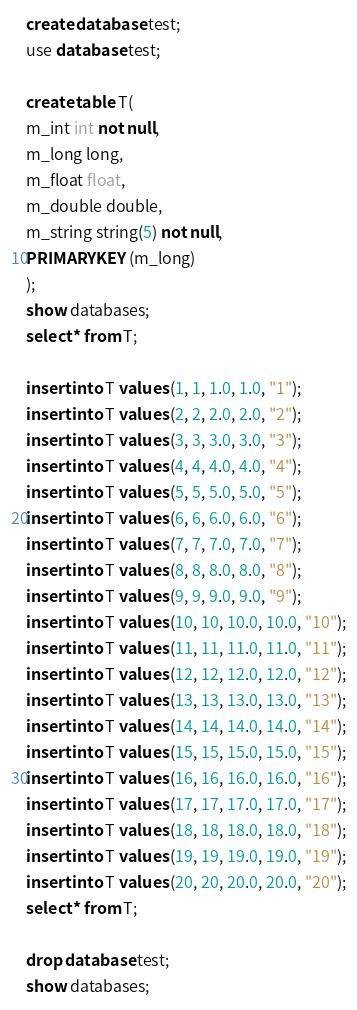Convert code to text. <code><loc_0><loc_0><loc_500><loc_500><_SQL_>create database test;
use database test;

create table T(
m_int int not null,
m_long long,
m_float float,
m_double double,
m_string string(5) not null,
PRIMARY KEY (m_long)
);
show databases;
select * from T;

insert into T values (1, 1, 1.0, 1.0, "1");
insert into T values (2, 2, 2.0, 2.0, "2");
insert into T values (3, 3, 3.0, 3.0, "3");
insert into T values (4, 4, 4.0, 4.0, "4");
insert into T values (5, 5, 5.0, 5.0, "5");
insert into T values (6, 6, 6.0, 6.0, "6");
insert into T values (7, 7, 7.0, 7.0, "7");
insert into T values (8, 8, 8.0, 8.0, "8");
insert into T values (9, 9, 9.0, 9.0, "9");
insert into T values (10, 10, 10.0, 10.0, "10");
insert into T values (11, 11, 11.0, 11.0, "11");
insert into T values (12, 12, 12.0, 12.0, "12");
insert into T values (13, 13, 13.0, 13.0, "13");
insert into T values (14, 14, 14.0, 14.0, "14");
insert into T values (15, 15, 15.0, 15.0, "15");
insert into T values (16, 16, 16.0, 16.0, "16");
insert into T values (17, 17, 17.0, 17.0, "17");
insert into T values (18, 18, 18.0, 18.0, "18");
insert into T values (19, 19, 19.0, 19.0, "19");
insert into T values (20, 20, 20.0, 20.0, "20");
select * from T;

drop database test;
show databases;
</code> 